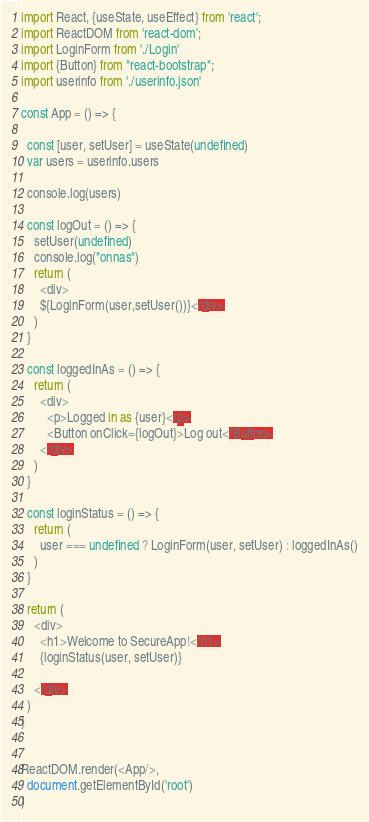Convert code to text. <code><loc_0><loc_0><loc_500><loc_500><_JavaScript_>import React, {useState, useEffect} from 'react';
import ReactDOM from 'react-dom';
import LoginForm from './Login'
import {Button} from "react-bootstrap";
import userinfo from './userinfo.json'

const App = () => {

  const [user, setUser] = useState(undefined)
  var users = userinfo.users

  console.log(users)

  const logOut = () => {
    setUser(undefined)
    console.log("onnas")
    return (
      <div>
      ${LoginForm(user,setUser())}</div>
    )
  }

  const loggedInAs = () => {
    return (
      <div>
        <p>Logged in as {user}</p>
        <Button onClick={logOut}>Log out</Button>
      </div>
    )
  }

  const loginStatus = () => {
    return (
      user === undefined ? LoginForm(user, setUser) : loggedInAs()
    )
  }

  return (
    <div>
      <h1>Welcome to SecureApp!</h1>
      {loginStatus(user, setUser)}

    </div>
  )
}


ReactDOM.render(<App/>,
  document.getElementById('root')
)
</code> 